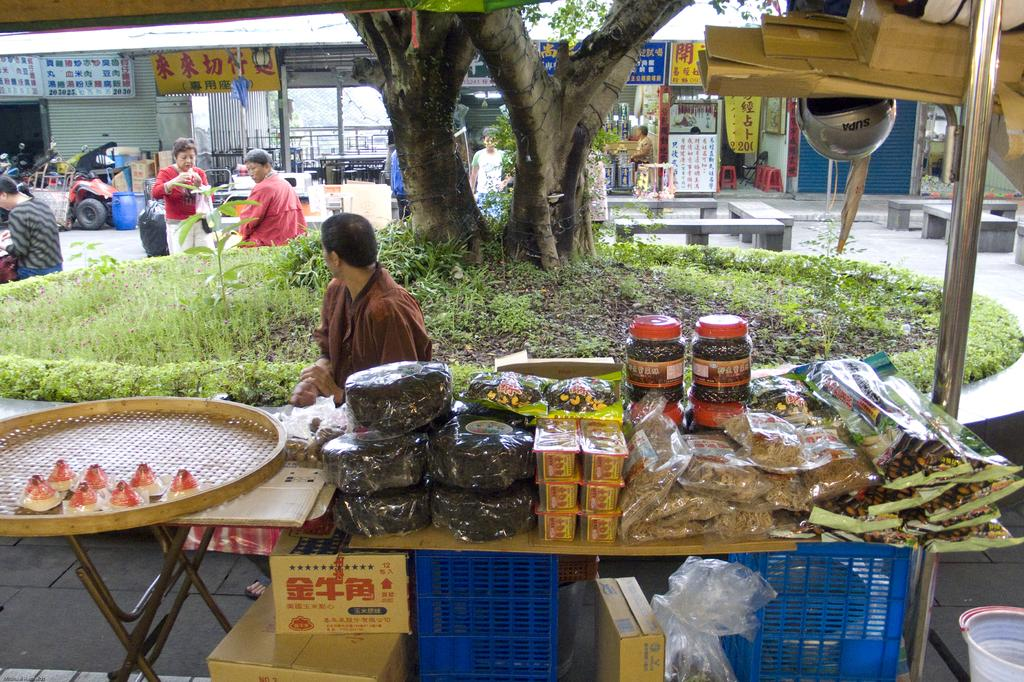What objects are on the table in the image? There are packets on the table in the image. What color are the baskets in the image? The baskets in the image are blue. What type of containers are present in the image? Cardboard boxes are present in the image. What natural elements can be seen in the image? Trees are visible in the image. Who or what is present in the image? There are people in the image. What type of establishments are shown in the image? Stores are present in the image. What material is used for the visible boards in the image? The boards visible in the image are made of an unspecified material. What type of seating is in the image? There is a red stool in the image. What mode of transportation is present in the image? Vehicles are present in the image. What type of signage is visible in the image? Banners are visible in the image. What rhythm does the detail in the eye of the person in the image follow? There is no mention of an eye or rhythm in the image, so this question cannot be answered. 